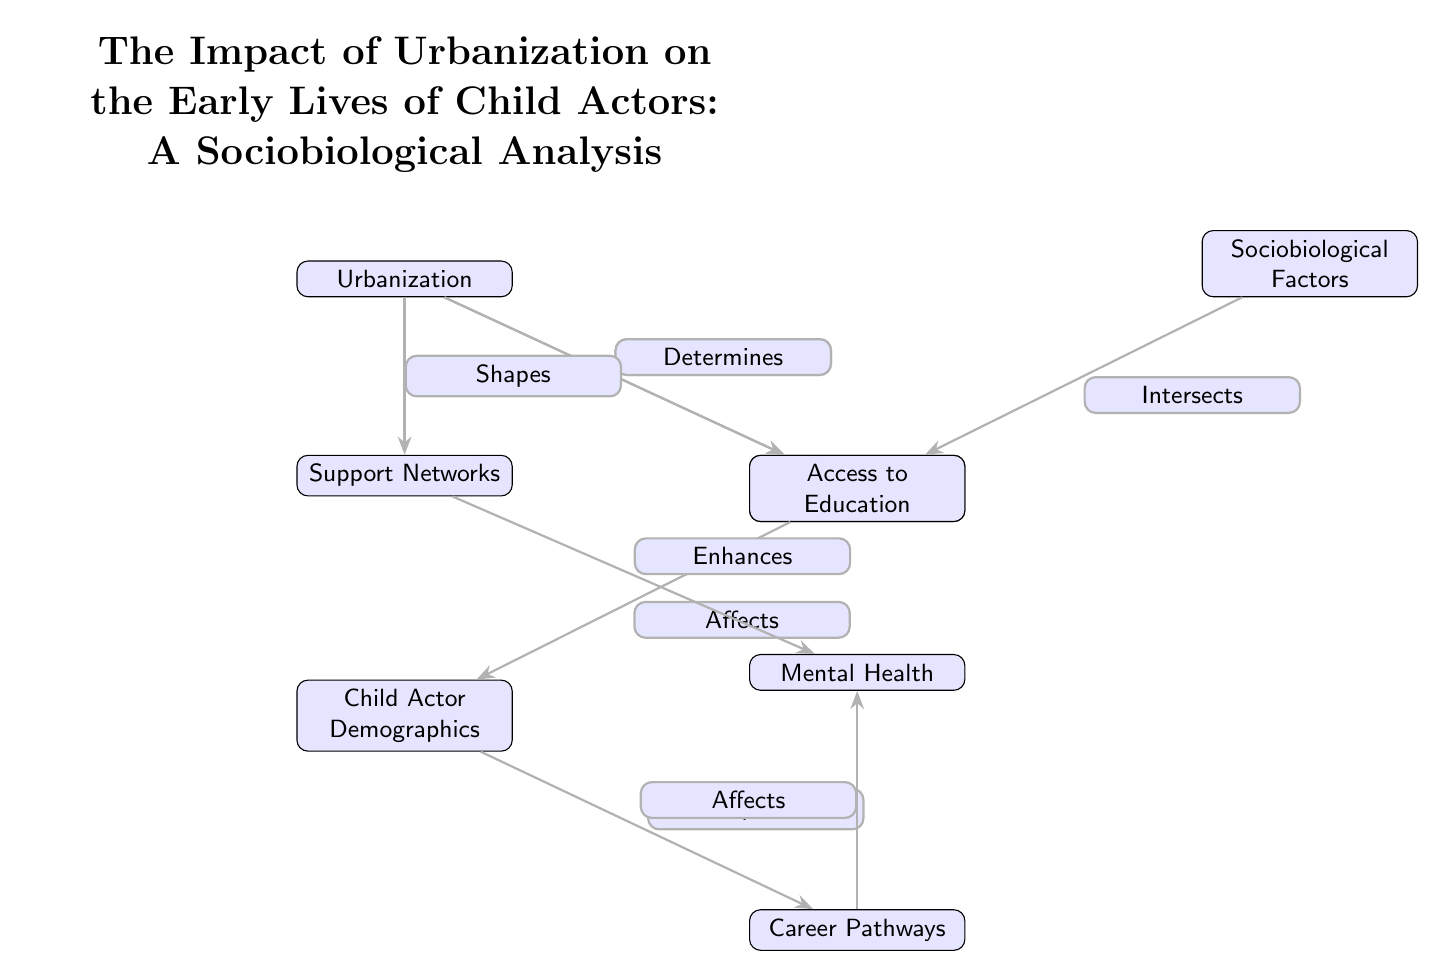What is the primary focus of the diagram? The diagram's title states, "The Impact of Urbanization on the Early Lives of Child Actors: A Sociobiological Analysis". This indicates the main theme is the effect of urbanization on the early lives of child actors, with a sociobiological perspective.
Answer: The Impact of Urbanization on the Early Lives of Child Actors How many main nodes are present in the diagram? The diagram consists of seven main nodes including Urbanization, Early Life Conditions, Child Actor Demographics, Sociobiological Factors, Access to Education, Career Pathways, and Support Networks. Counting these gives a total of seven nodes.
Answer: Seven What influences Early Life Conditions according to the diagram? According to the diagram, Urbanization influences Early Life Conditions, as indicated by the edge labeled "Influences".
Answer: Urbanization What does Access to Education depend on? The diagram indicates that Access to Education is determined by Urbanization, as represented by the edge labeled "Determines" pointing towards Access to Education from Urbanization.
Answer: Urbanization How does Support Networks relate to Mental Health? The diagram shows that Support Networks enhances Mental Health as indicated by the edge labeled "Enhances" between these two nodes.
Answer: Enhances What is the connection between Career Pathways and Child Actor Demographics? The Career Pathways are impacted by Child Actor Demographics according to the diagram, as shown by the edge labeled "Impacts" pointing from Child Actor Demographics to Career Pathways.
Answer: Impacts Which two nodes intersect with Early Life Conditions? Early Life Conditions intersects with Child Actor Demographics and Sociobiological Factors, as indicated by the edges leading to Early Life Conditions from both nodes.
Answer: Child Actor Demographics and Sociobiological Factors In which direction does the influence flow from Urbanization to Support Networks? The influence flows from Urbanization, as indicated by the arrow labeled "Shapes" leading to Support Networks. This signifies that Urbanization shapes Support Networks.
Answer: Shapes What is the relationship between Sociobiological Factors and Early Life Conditions? The relationship is that Sociobiological Factors intersect with Early Life Conditions, as represented by the arrow labeled "Intersects" from Sociobiological Factors to Early Life Conditions.
Answer: Intersects 